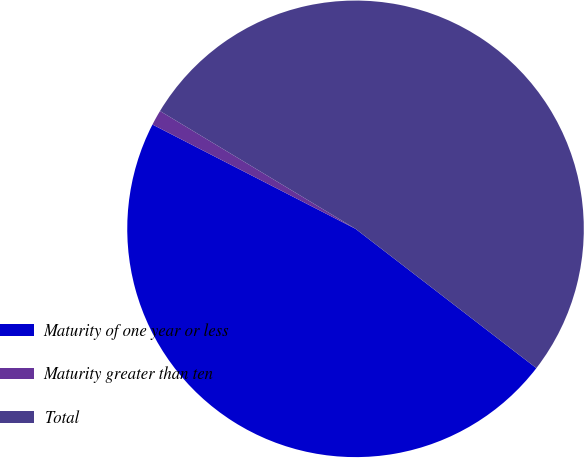Convert chart to OTSL. <chart><loc_0><loc_0><loc_500><loc_500><pie_chart><fcel>Maturity of one year or less<fcel>Maturity greater than ten<fcel>Total<nl><fcel>47.11%<fcel>1.08%<fcel>51.82%<nl></chart> 